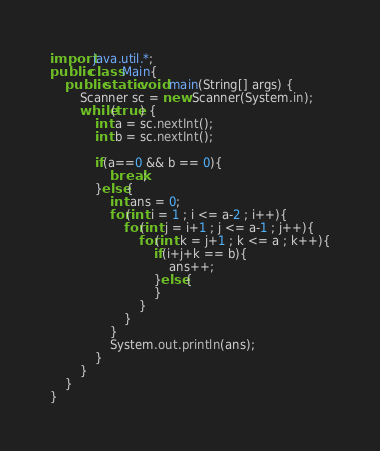<code> <loc_0><loc_0><loc_500><loc_500><_Java_>import java.util.*;
public class Main{
    public static void main(String[] args) {
        Scanner sc = new Scanner(System.in);
        while(true) {
            int a = sc.nextInt();
            int b = sc.nextInt();

            if(a==0 && b == 0){
                break;
            }else{
                int ans = 0;
                for(int i = 1 ; i <= a-2 ; i++){
                    for(int j = i+1 ; j <= a-1 ; j++){
                        for(int k = j+1 ; k <= a ; k++){
                            if(i+j+k == b){
                                ans++;
                            }else{
                            }
                        }
                    }
                }
                System.out.println(ans);
            }
        }
    }
}

</code> 